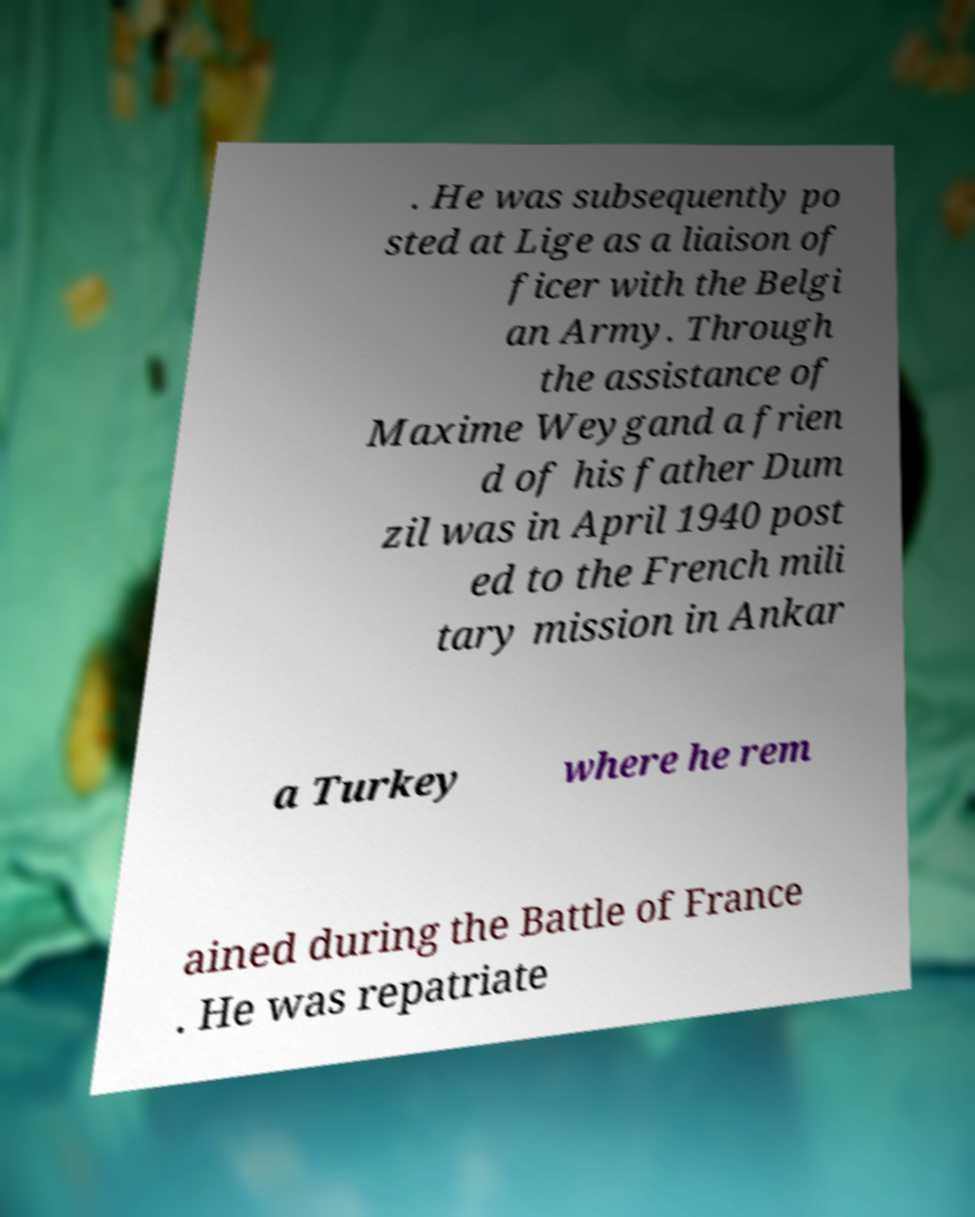For documentation purposes, I need the text within this image transcribed. Could you provide that? . He was subsequently po sted at Lige as a liaison of ficer with the Belgi an Army. Through the assistance of Maxime Weygand a frien d of his father Dum zil was in April 1940 post ed to the French mili tary mission in Ankar a Turkey where he rem ained during the Battle of France . He was repatriate 